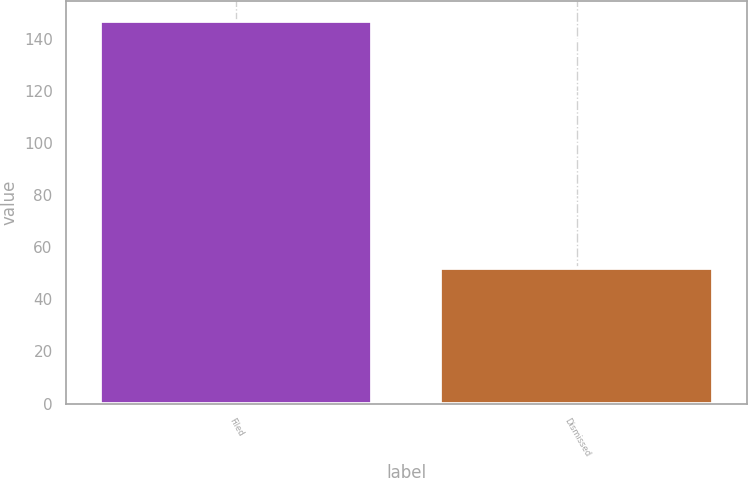Convert chart. <chart><loc_0><loc_0><loc_500><loc_500><bar_chart><fcel>Filed<fcel>Dismissed<nl><fcel>147<fcel>52<nl></chart> 